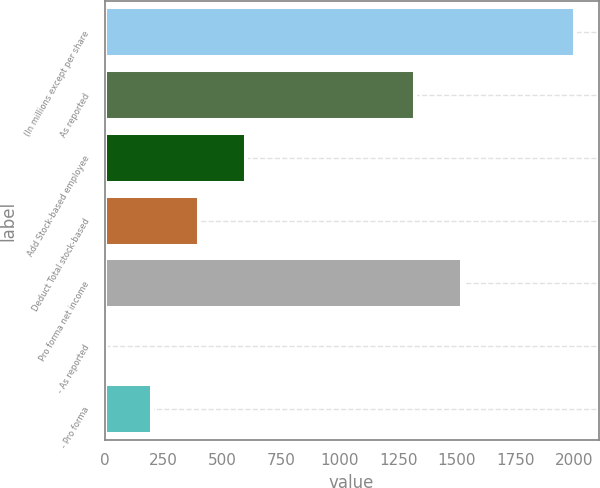Convert chart to OTSL. <chart><loc_0><loc_0><loc_500><loc_500><bar_chart><fcel>(In millions except per share<fcel>As reported<fcel>Add Stock-based employee<fcel>Deduct Total stock-based<fcel>Pro forma net income<fcel>- As reported<fcel>- Pro forma<nl><fcel>2003<fcel>1321<fcel>603.87<fcel>404<fcel>1520.87<fcel>4.26<fcel>204.13<nl></chart> 